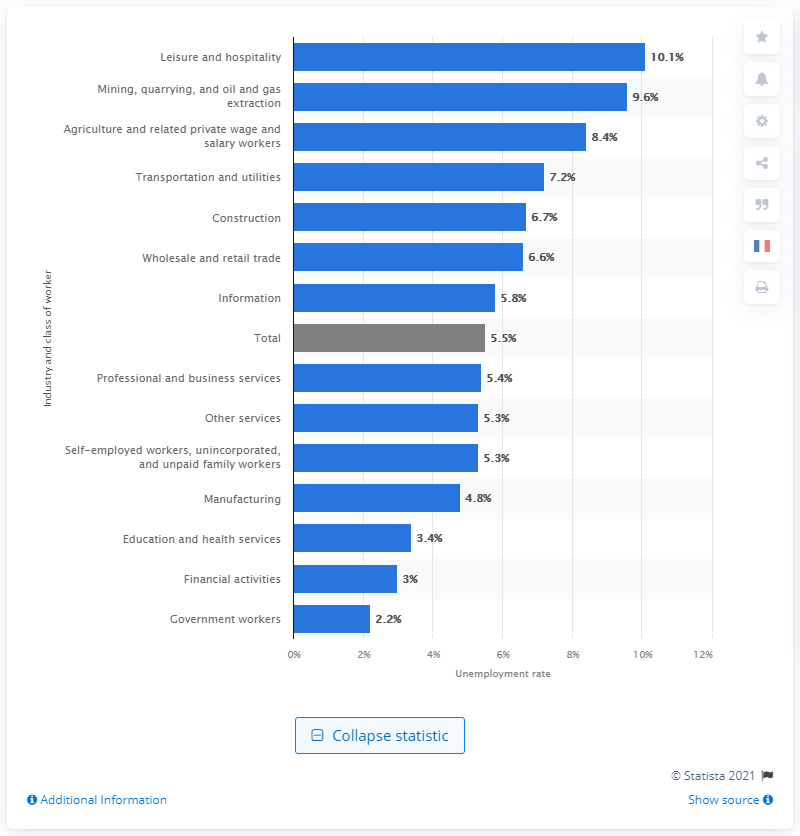Outline some significant characteristics in this image. The average unemployment rate for all industries was 5.5%. The lowest unemployment rate for government workers was 2.2%. 